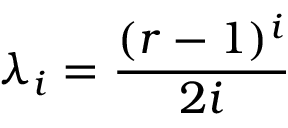Convert formula to latex. <formula><loc_0><loc_0><loc_500><loc_500>\lambda _ { i } = { \frac { ( r - 1 ) ^ { i } } { 2 i } }</formula> 